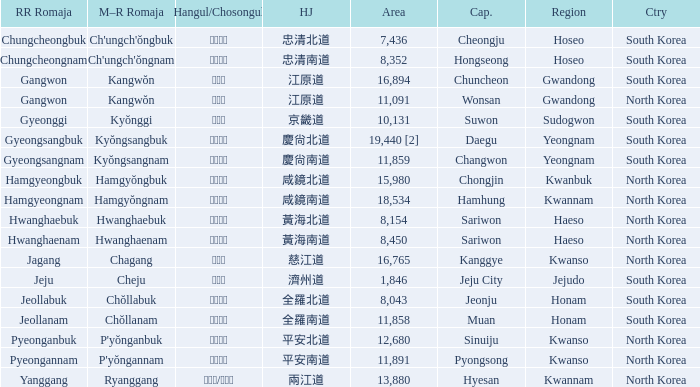Which country has a city with a Hanja of 平安北道? North Korea. 